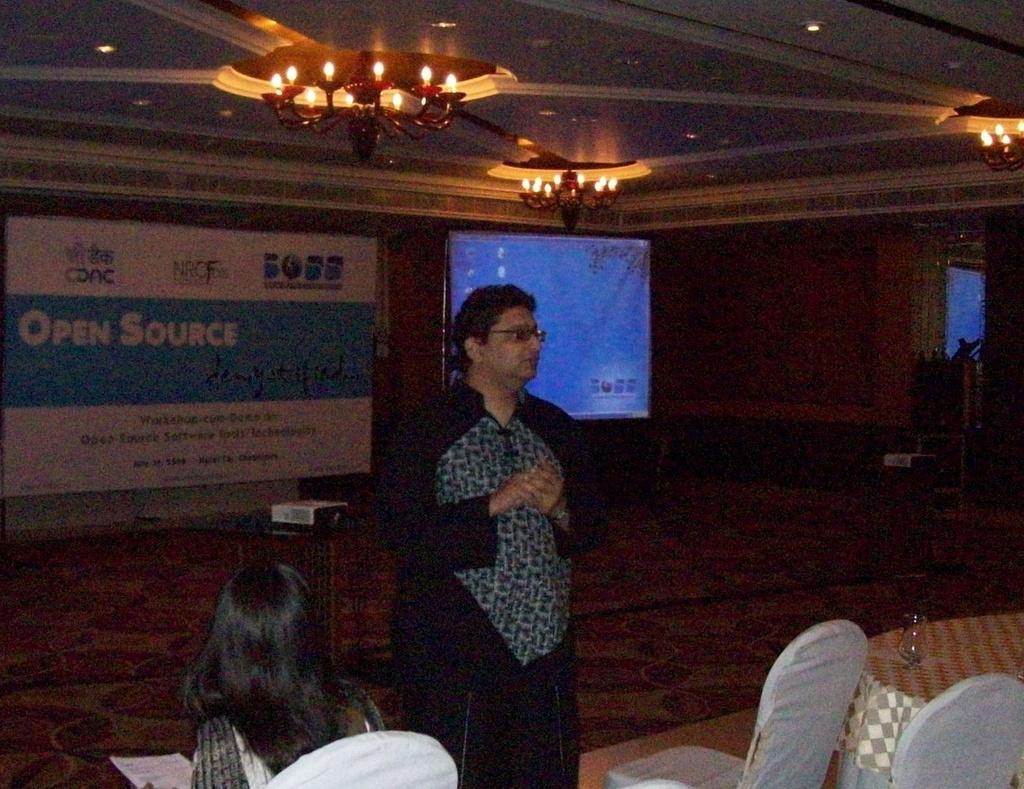Please provide a concise description of this image. In this picture there is a man in the center of the image and there is a lady who is sitting on the chair at the bottom side of the image, there is a table and chairs at the bottom side of the image and there is a poster and a projector screen in the background area of the image. 